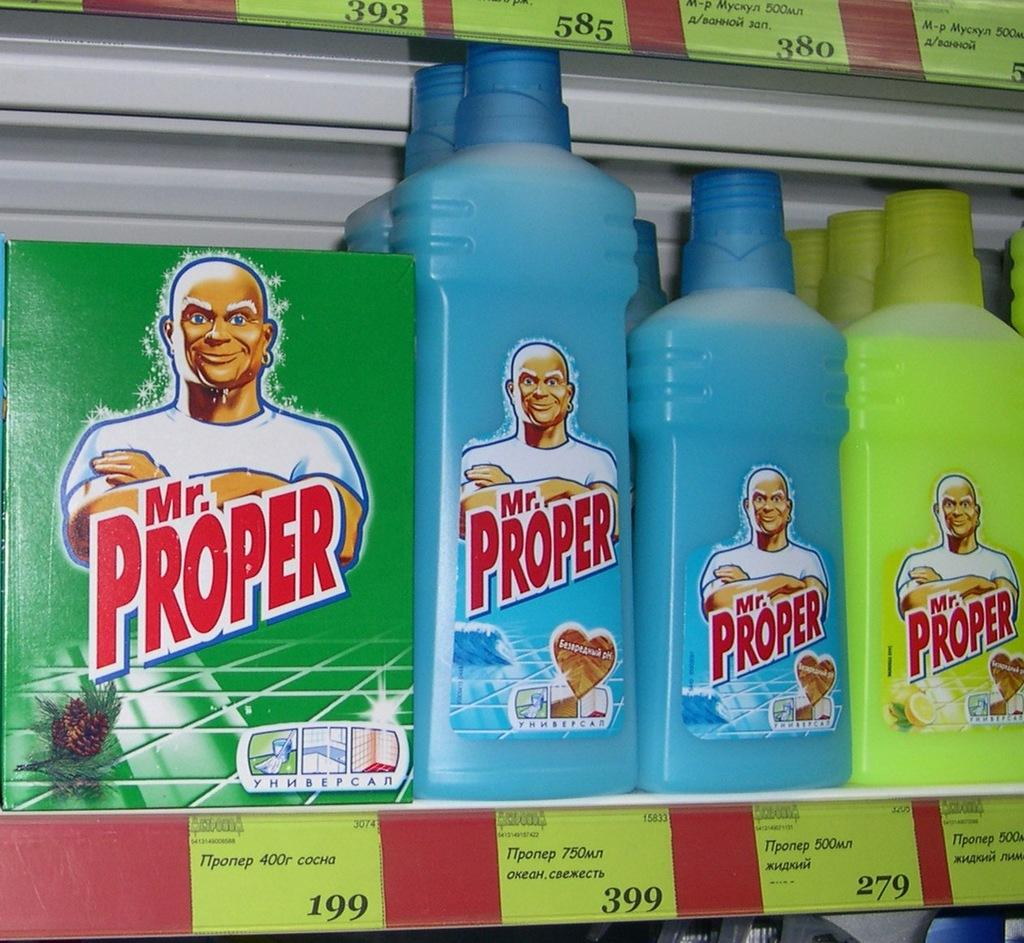What is the main object in the image? There is a rack in the image. What is placed on the rack? There are bottles and a box on the rack. What is the brand of the items on the rack? The bottles and box are labeled as "Mr. Proper." What else can be seen on the rack? There are different types of tags on the rack. What type of engine is visible on the rack in the image? There is no engine present in the image; the image features a rack with bottles and a box labeled as "Mr. Proper" and different types of tags. 